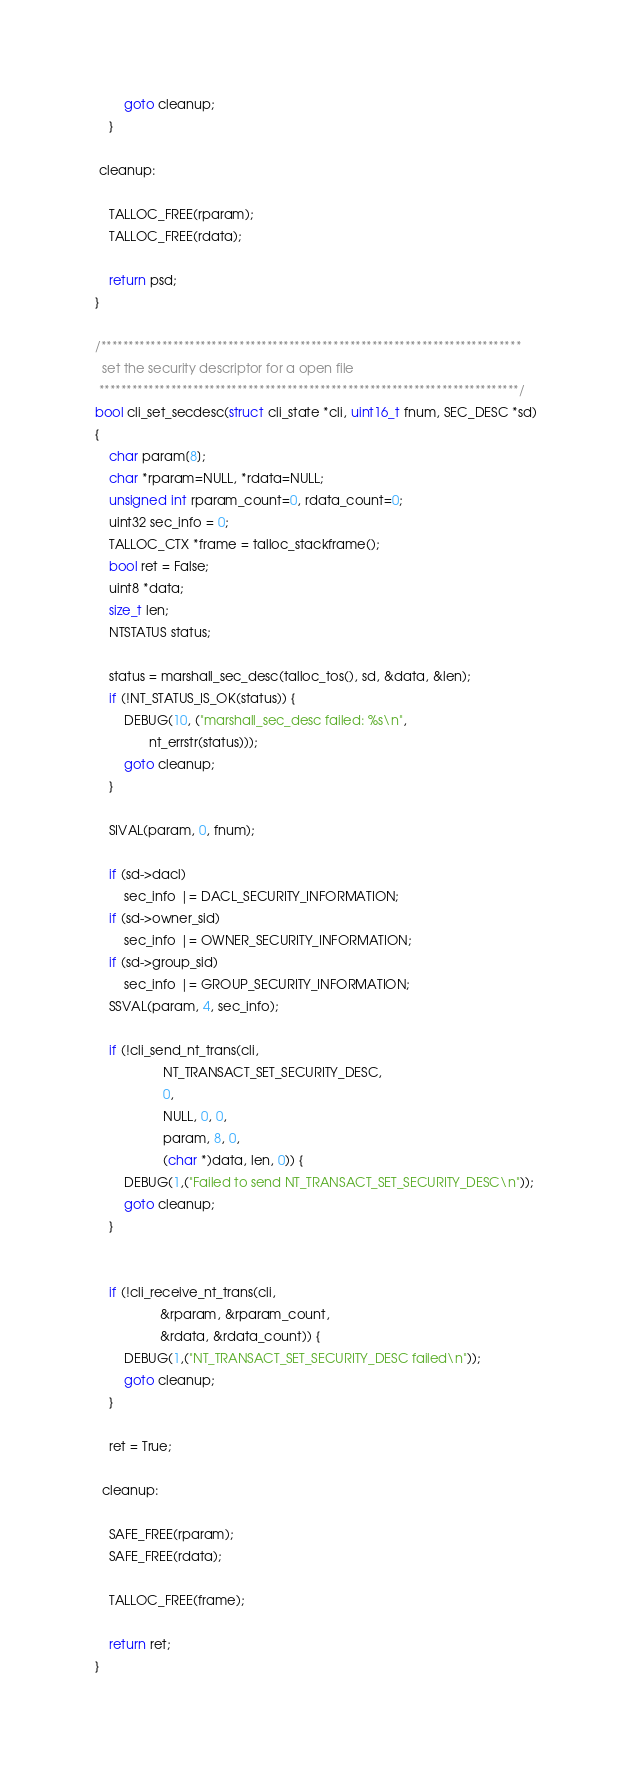<code> <loc_0><loc_0><loc_500><loc_500><_C_>		goto cleanup;
	}

 cleanup:

	TALLOC_FREE(rparam);
	TALLOC_FREE(rdata);

	return psd;
}

/****************************************************************************
  set the security descriptor for a open file
 ****************************************************************************/
bool cli_set_secdesc(struct cli_state *cli, uint16_t fnum, SEC_DESC *sd)
{
	char param[8];
	char *rparam=NULL, *rdata=NULL;
	unsigned int rparam_count=0, rdata_count=0;
	uint32 sec_info = 0;
	TALLOC_CTX *frame = talloc_stackframe();
	bool ret = False;
	uint8 *data;
	size_t len;
	NTSTATUS status;

	status = marshall_sec_desc(talloc_tos(), sd, &data, &len);
	if (!NT_STATUS_IS_OK(status)) {
		DEBUG(10, ("marshall_sec_desc failed: %s\n",
			   nt_errstr(status)));
		goto cleanup;
	}

	SIVAL(param, 0, fnum);

	if (sd->dacl)
		sec_info |= DACL_SECURITY_INFORMATION;
	if (sd->owner_sid)
		sec_info |= OWNER_SECURITY_INFORMATION;
	if (sd->group_sid)
		sec_info |= GROUP_SECURITY_INFORMATION;
	SSVAL(param, 4, sec_info);

	if (!cli_send_nt_trans(cli, 
			       NT_TRANSACT_SET_SECURITY_DESC, 
			       0, 
			       NULL, 0, 0,
			       param, 8, 0,
			       (char *)data, len, 0)) {
		DEBUG(1,("Failed to send NT_TRANSACT_SET_SECURITY_DESC\n"));
		goto cleanup;
	}


	if (!cli_receive_nt_trans(cli, 
				  &rparam, &rparam_count,
				  &rdata, &rdata_count)) {
		DEBUG(1,("NT_TRANSACT_SET_SECURITY_DESC failed\n"));
		goto cleanup;
	}

	ret = True;

  cleanup:

	SAFE_FREE(rparam);
	SAFE_FREE(rdata);

	TALLOC_FREE(frame);

	return ret;
}
</code> 